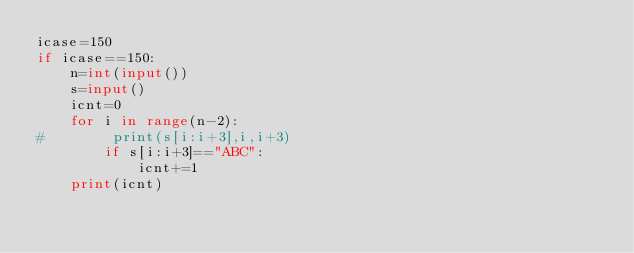<code> <loc_0><loc_0><loc_500><loc_500><_Python_>icase=150
if icase==150:
    n=int(input())
    s=input()
    icnt=0
    for i in range(n-2):
#        print(s[i:i+3],i,i+3)
        if s[i:i+3]=="ABC":
            icnt+=1
    print(icnt)
</code> 